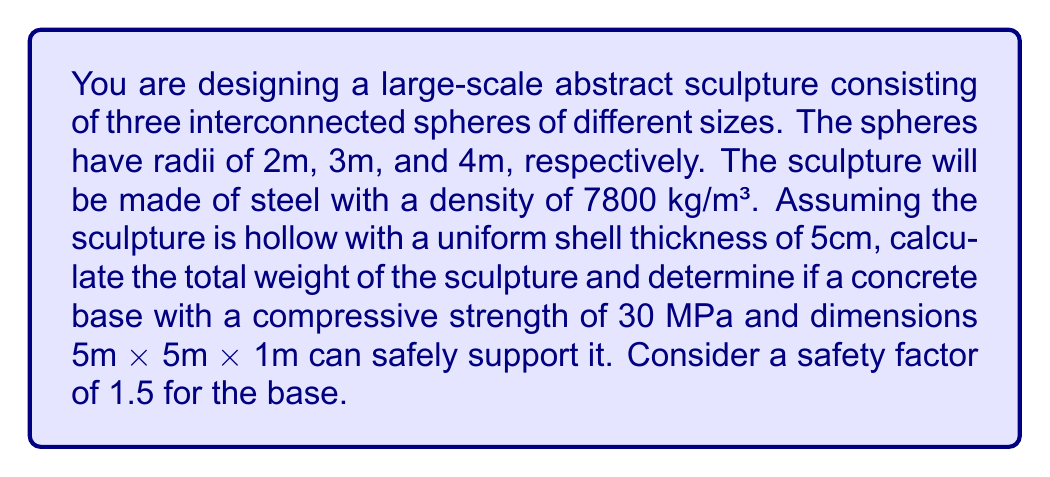Can you solve this math problem? 1. Calculate the volume of each sphere's shell:
   For a sphere with radius $r$ and thickness $t$, the shell volume is:
   $$V = \frac{4}{3}\pi((r+t)^3 - r^3)$$

   Sphere 1: $$V_1 = \frac{4}{3}\pi((2.05^3 - 2^3)) = 2.56 \text{ m}^3$$
   Sphere 2: $$V_2 = \frac{4}{3}\pi((3.05^3 - 3^3)) = 5.77 \text{ m}^3$$
   Sphere 3: $$V_3 = \frac{4}{3}\pi((4.05^3 - 4^3)) = 10.18 \text{ m}^3$$

2. Calculate the total volume:
   $$V_{total} = V_1 + V_2 + V_3 = 18.51 \text{ m}^3$$

3. Calculate the weight of the sculpture:
   $$W = V_{total} \times \text{density} = 18.51 \times 7800 = 144,378 \text{ kg} = 1,415,547 \text{ N}$$

4. Calculate the pressure exerted on the base:
   Base area: $$A = 5 \text{ m} \times 5 \text{ m} = 25 \text{ m}^2$$
   Pressure: $$P = \frac{W}{A} = \frac{1,415,547}{25} = 56,622 \text{ N/m}^2 = 0.057 \text{ MPa}$$

5. Check if the base can support the sculpture:
   Maximum allowed pressure with safety factor:
   $$P_{max} = \frac{30 \text{ MPa}}{1.5} = 20 \text{ MPa}$$

   Since $0.057 \text{ MPa} < 20 \text{ MPa}$, the base can safely support the sculpture.
Answer: Yes, the base can safely support the 144,378 kg sculpture. 